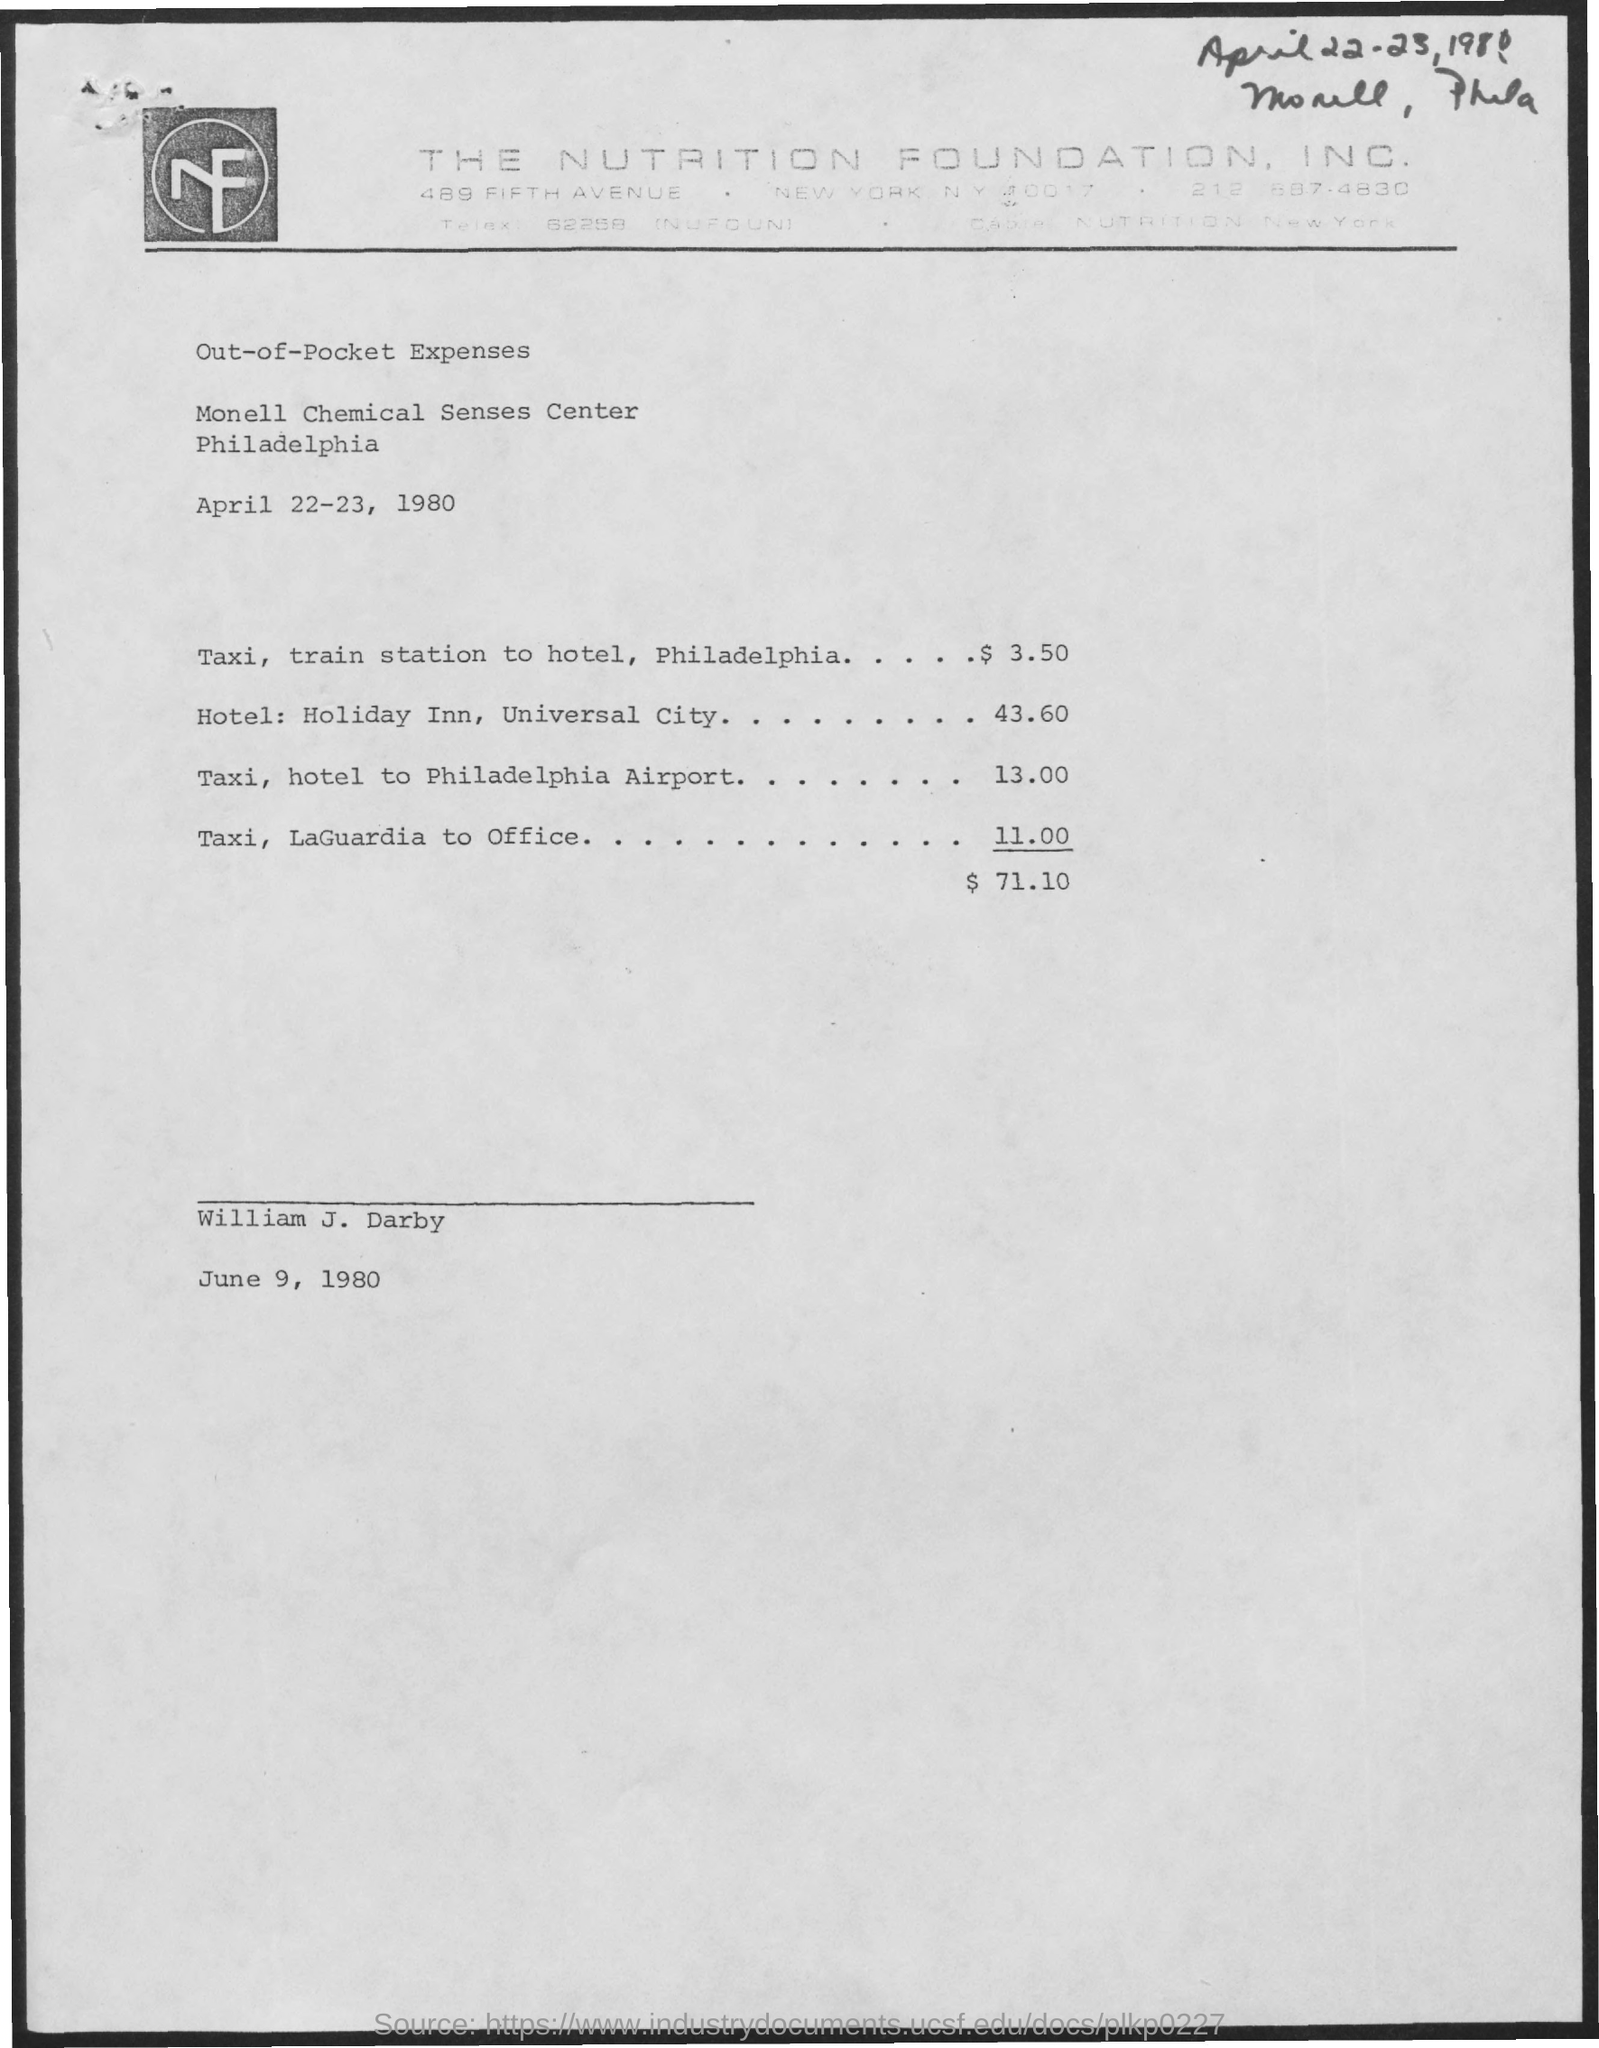Highlight a few significant elements in this photo. The Monell Chemical Senses Center is located in Philadelphia. Out-of-pocket expenses from April 22-23, 1980, belong to the period for which they were incurred. The cost for a taxi and hotel to Philadelphia Airport is $13.00. The cost for a taxi from LaGuardia Airport to the office is $11.00. The total amount of out-of-pocket expenses is $71.10. 